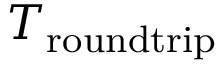<formula> <loc_0><loc_0><loc_500><loc_500>T _ { r o u n d t r i p }</formula> 